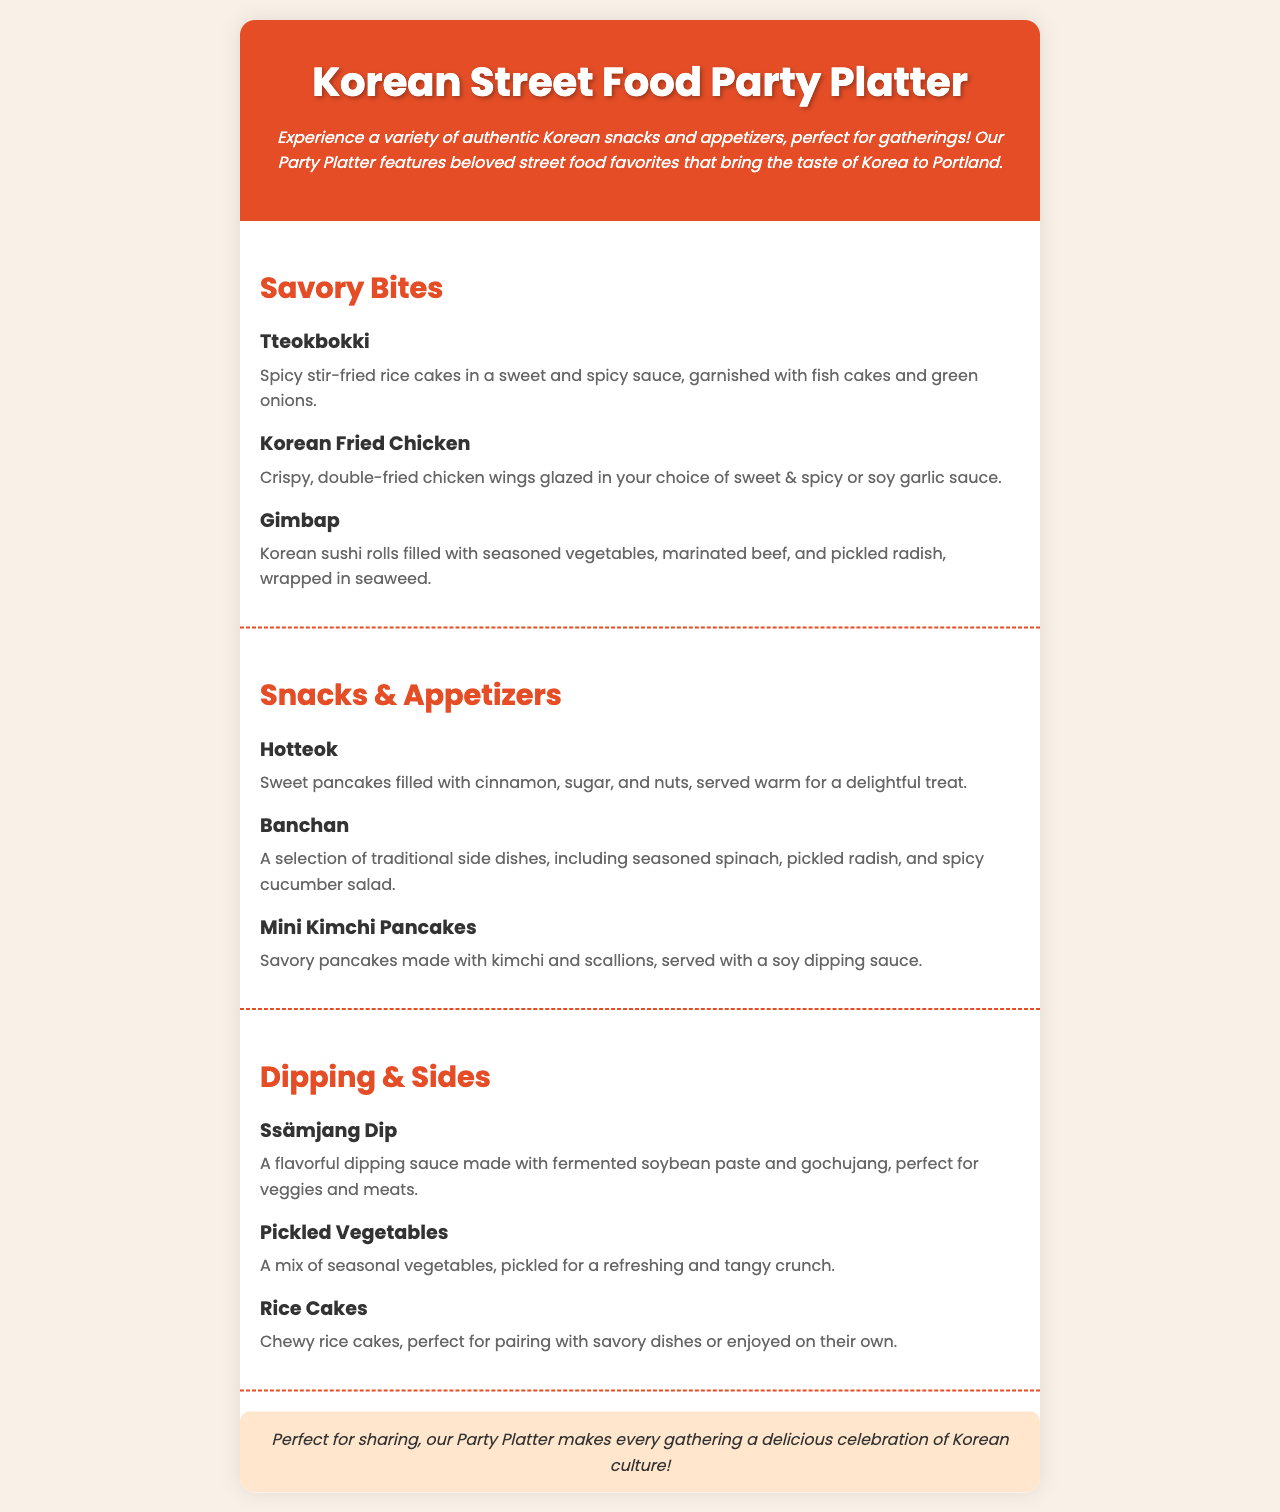What is the title of the menu? The title of the menu is found in the header section.
Answer: Korean Street Food Party Platter How many menu sections are there? The document contains three main menu sections: Savory Bites, Snacks & Appetizers, and Dipping & Sides.
Answer: Three What ingredient garnishes the Tteokbokki? The ingredient that garnishes Tteokbokki is mentioned in the description below the item.
Answer: Fish cakes and green onions What type of dipping sauce is used with Mini Kimchi Pancakes? The sauce accompanying Mini Kimchi Pancakes is specified in the description.
Answer: Soy dipping sauce What is included in the Banchan? The Banchan includes traditional side dishes as listed in the menu item.
Answer: Seasoned spinach, pickled radish, spicy cucumber salad Which item is described as a "delightful treat"? The phrase “delightful treat” refers to the item found in the Snacks & Appetizers section.
Answer: Hotteok What is the main flavor of the Ssämjang Dip? The flavor of Ssämjang Dip is indicated in the description of the dipping sauce.
Answer: Fermented soybean paste and gochujang What type of pancakes are served in the Snacks & Appetizers? The type of pancakes mentioned in the Snacks & Appetizers section is specified in the menu item description.
Answer: Mini Kimchi Pancakes 